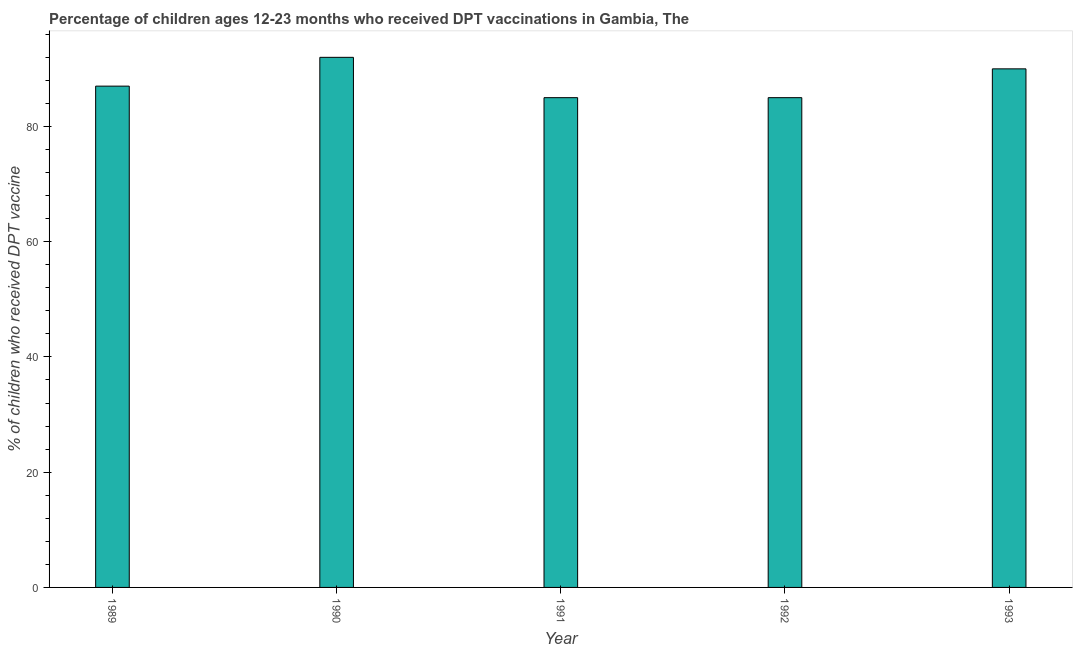Does the graph contain grids?
Your response must be concise. No. What is the title of the graph?
Ensure brevity in your answer.  Percentage of children ages 12-23 months who received DPT vaccinations in Gambia, The. What is the label or title of the X-axis?
Offer a terse response. Year. What is the label or title of the Y-axis?
Provide a succinct answer. % of children who received DPT vaccine. Across all years, what is the maximum percentage of children who received dpt vaccine?
Make the answer very short. 92. In which year was the percentage of children who received dpt vaccine maximum?
Provide a succinct answer. 1990. What is the sum of the percentage of children who received dpt vaccine?
Provide a succinct answer. 439. What is the ratio of the percentage of children who received dpt vaccine in 1989 to that in 1990?
Make the answer very short. 0.95. What is the difference between the highest and the second highest percentage of children who received dpt vaccine?
Offer a very short reply. 2. Is the sum of the percentage of children who received dpt vaccine in 1989 and 1991 greater than the maximum percentage of children who received dpt vaccine across all years?
Offer a terse response. Yes. In how many years, is the percentage of children who received dpt vaccine greater than the average percentage of children who received dpt vaccine taken over all years?
Your response must be concise. 2. How many bars are there?
Your response must be concise. 5. Are all the bars in the graph horizontal?
Offer a terse response. No. How many years are there in the graph?
Offer a terse response. 5. What is the difference between two consecutive major ticks on the Y-axis?
Ensure brevity in your answer.  20. Are the values on the major ticks of Y-axis written in scientific E-notation?
Give a very brief answer. No. What is the % of children who received DPT vaccine in 1990?
Give a very brief answer. 92. What is the % of children who received DPT vaccine of 1992?
Make the answer very short. 85. What is the difference between the % of children who received DPT vaccine in 1989 and 1990?
Give a very brief answer. -5. What is the difference between the % of children who received DPT vaccine in 1989 and 1992?
Give a very brief answer. 2. What is the difference between the % of children who received DPT vaccine in 1990 and 1991?
Your answer should be compact. 7. What is the difference between the % of children who received DPT vaccine in 1990 and 1992?
Your response must be concise. 7. What is the difference between the % of children who received DPT vaccine in 1992 and 1993?
Give a very brief answer. -5. What is the ratio of the % of children who received DPT vaccine in 1989 to that in 1990?
Your answer should be very brief. 0.95. What is the ratio of the % of children who received DPT vaccine in 1989 to that in 1992?
Provide a short and direct response. 1.02. What is the ratio of the % of children who received DPT vaccine in 1990 to that in 1991?
Your answer should be very brief. 1.08. What is the ratio of the % of children who received DPT vaccine in 1990 to that in 1992?
Keep it short and to the point. 1.08. What is the ratio of the % of children who received DPT vaccine in 1990 to that in 1993?
Ensure brevity in your answer.  1.02. What is the ratio of the % of children who received DPT vaccine in 1991 to that in 1993?
Provide a short and direct response. 0.94. What is the ratio of the % of children who received DPT vaccine in 1992 to that in 1993?
Offer a terse response. 0.94. 